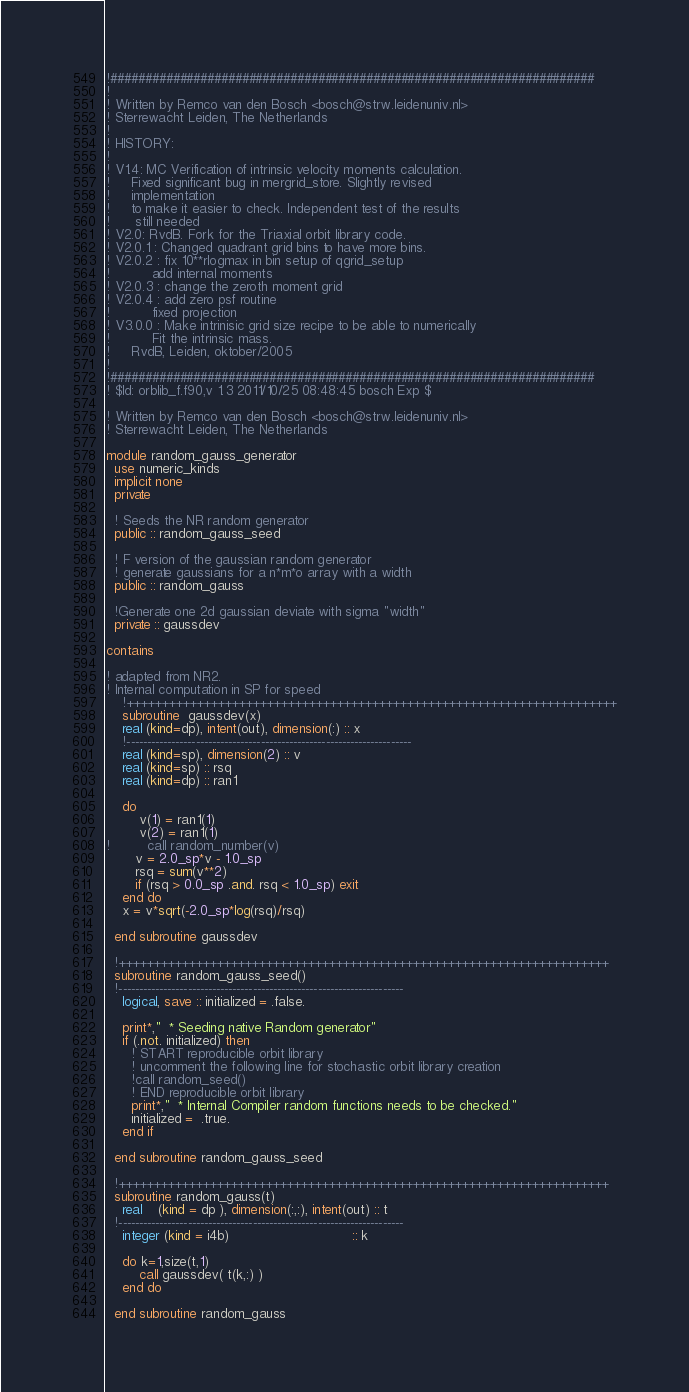Convert code to text. <code><loc_0><loc_0><loc_500><loc_500><_FORTRAN_>!######################################################################
!
! Written by Remco van den Bosch <bosch@strw.leidenuniv.nl>
! Sterrewacht Leiden, The Netherlands
!
! HISTORY:
!
! V1.4: MC Verification of intrinsic velocity moments calculation.
!     Fixed significant bug in mergrid_store. Slightly revised 
!     implementation
!     to make it easier to check. Independent test of the results 
!      still needed
! V2.0: RvdB. Fork for the Triaxial orbit library code.
! V2.0.1 : Changed quadrant grid bins to have more bins.
! V2.0.2 : fix 10**rlogmax in bin setup of qgrid_setup
!          add internal moments
! V2.0.3 : change the zeroth moment grid
! V2.0.4 : add zero psf routine
!          fixed projection
! V3.0.0 : Make intrinisic grid size recipe to be able to numerically  
!          Fit the intrinsic mass.
!     RvdB, Leiden, oktober/2005
!
!######################################################################
! $Id: orblib_f.f90,v 1.3 2011/10/25 08:48:45 bosch Exp $

! Written by Remco van den Bosch <bosch@strw.leidenuniv.nl>
! Sterrewacht Leiden, The Netherlands

module random_gauss_generator
  use numeric_kinds
  implicit none
  private

  ! Seeds the NR random generator
  public :: random_gauss_seed

  ! F version of the gaussian random generator
  ! generate gaussians for a n*m*o array with a width
  public :: random_gauss

  !Generate one 2d gaussian deviate with sigma "width"
  private :: gaussdev

contains

! adapted from NR2.
! Internal computation in SP for speed
    !++++++++++++++++++++++++++++++++++++++++++++++++++++++++++++++++++++++
    subroutine  gaussdev(x)
    real (kind=dp), intent(out), dimension(:) :: x
    !----------------------------------------------------------------------
    real (kind=sp), dimension(2) :: v
    real (kind=sp) :: rsq
    real (kind=dp) :: ran1

    do
        v(1) = ran1(1)
        v(2) = ran1(1)
!         call random_number(v)
       v = 2.0_sp*v - 1.0_sp
       rsq = sum(v**2)
       if (rsq > 0.0_sp .and. rsq < 1.0_sp) exit
    end do
    x = v*sqrt(-2.0_sp*log(rsq)/rsq)

  end subroutine gaussdev

  !++++++++++++++++++++++++++++++++++++++++++++++++++++++++++++++++++++++
  subroutine random_gauss_seed()
  !----------------------------------------------------------------------
    logical, save :: initialized = .false.

    print*,"  * Seeding native Random generator"
    if (.not. initialized) then
      ! START reproducible orbit library
      ! uncomment the following line for stochastic orbit library creation
      !call random_seed()
      ! END reproducible orbit library
      print*,"  * Internal Compiler random functions needs to be checked."
      initialized =  .true.
    end if

  end subroutine random_gauss_seed

  !++++++++++++++++++++++++++++++++++++++++++++++++++++++++++++++++++++++
  subroutine random_gauss(t)
    real    (kind = dp ), dimension(:,:), intent(out) :: t
  !----------------------------------------------------------------------
    integer (kind = i4b)                              :: k

    do k=1,size(t,1)
        call gaussdev( t(k,:) )
    end do

  end subroutine random_gauss
</code> 